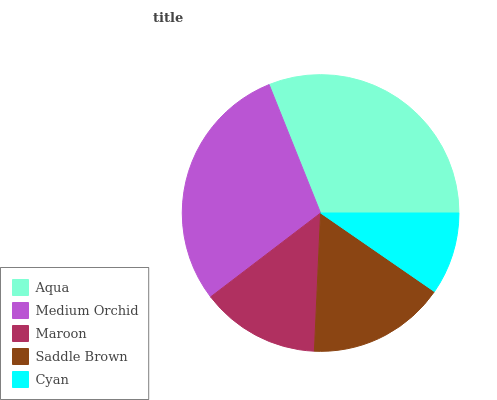Is Cyan the minimum?
Answer yes or no. Yes. Is Aqua the maximum?
Answer yes or no. Yes. Is Medium Orchid the minimum?
Answer yes or no. No. Is Medium Orchid the maximum?
Answer yes or no. No. Is Aqua greater than Medium Orchid?
Answer yes or no. Yes. Is Medium Orchid less than Aqua?
Answer yes or no. Yes. Is Medium Orchid greater than Aqua?
Answer yes or no. No. Is Aqua less than Medium Orchid?
Answer yes or no. No. Is Saddle Brown the high median?
Answer yes or no. Yes. Is Saddle Brown the low median?
Answer yes or no. Yes. Is Medium Orchid the high median?
Answer yes or no. No. Is Maroon the low median?
Answer yes or no. No. 